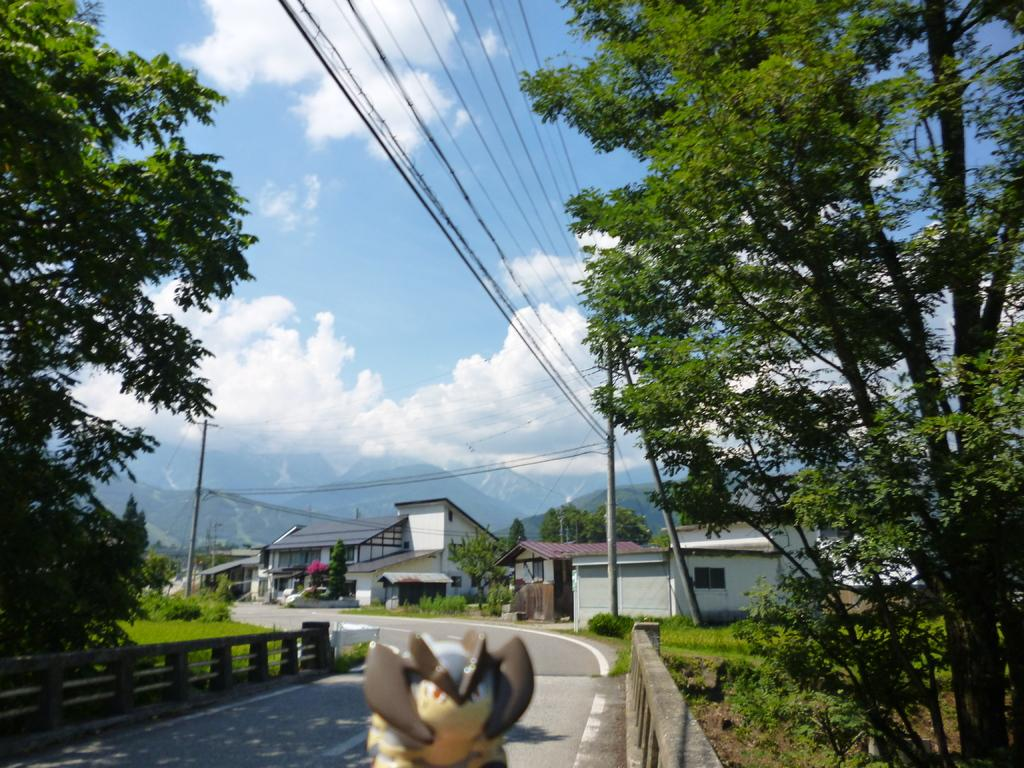What object can be seen in the image that is typically used for play? There is a toy in the image. What type of path is visible in the image? There is a road in the image. What type of vegetation is present in the image? There is grass in the image. What type of structures can be seen in the image? There are buildings in the image. What type of barrier is present in the image? There are fences in the image. What type of natural feature is present in the image? There are trees in the image. What type of vertical structures are present in the image? There are poles in the image. What type of man-made structures are present in the image? There are wires in the image. What can be seen in the background of the image? The sky is visible in the background of the image. Can you see the sun shining through the window in the image? There is no window present in the image, and the sun is not visible in the background. 